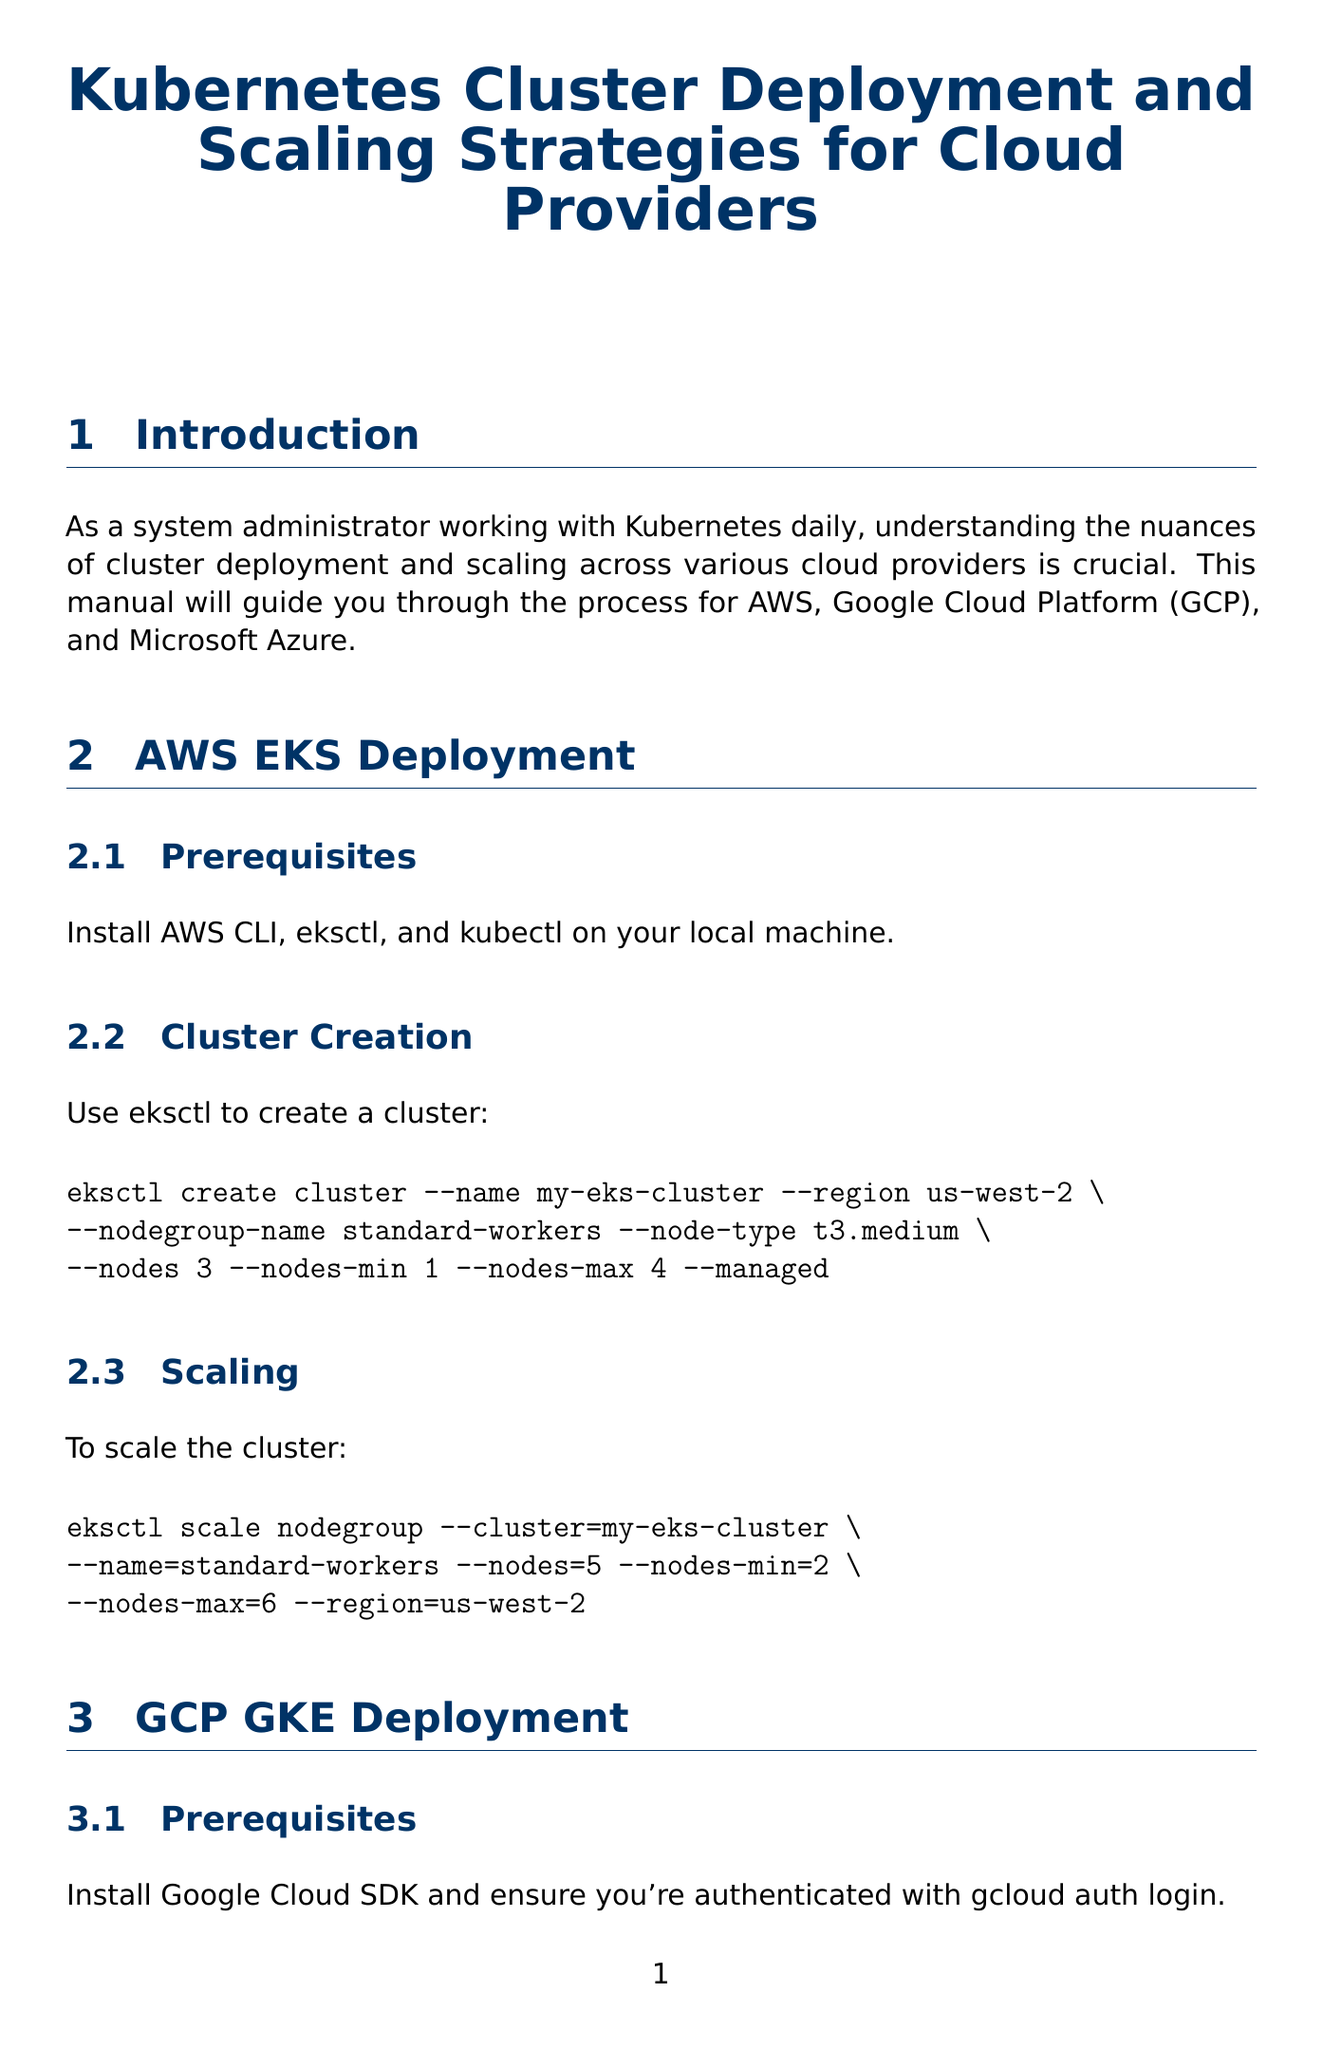What is the title of the document? The title of the document is provided at the beginning, presented clearly.
Answer: Kubernetes Cluster Deployment and Scaling Strategies for Cloud Providers What command creates an AWS EKS cluster? The document specifies the command to create a cluster under the AWS EKS Deployment section.
Answer: eksctl create cluster --name my-eks-cluster --region us-west-2 --nodegroup-name standard-workers --node-type t3.medium --nodes 3 --nodes-min 1 --nodes-max 4 --managed What is the minimum number of nodes in the AWS EKS scaling command? The minimum number of nodes is specified in the scaling section of the AWS EKS Deployment.
Answer: 2 Which tool is used to install Prometheus and Grafana? The installation process for Prometheus and Grafana references a specific tool under the Monitoring and Logging section.
Answer: Helm What is the command to backup etcd? The document outlines the command to backup etcd in the Disaster Recovery section.
Answer: etcdctl snapshot save snapshot.db What strategy does the document mention for multi-cloud management? The document lists a specific option for multi-cloud management under the Multi-Cloud Strategies section.
Answer: Google Anthos How many nodes does the GCP GKE cluster start with? The number of initial nodes is stated in the GCP GKE Deployment section.
Answer: 3 Which cloud provider is associated with Velero installation? The provider linked to Velero installation is mentioned in the Disaster Recovery section.
Answer: AWS 